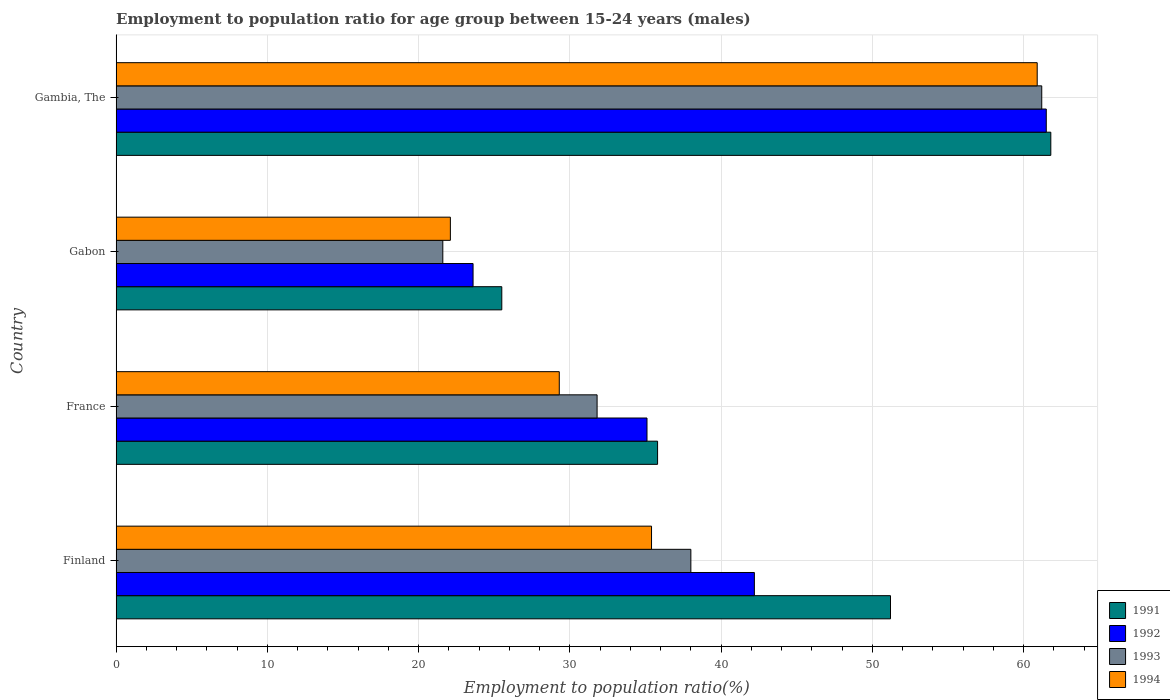Are the number of bars on each tick of the Y-axis equal?
Your response must be concise. Yes. How many bars are there on the 1st tick from the top?
Provide a succinct answer. 4. What is the label of the 3rd group of bars from the top?
Your answer should be compact. France. In how many cases, is the number of bars for a given country not equal to the number of legend labels?
Offer a very short reply. 0. What is the employment to population ratio in 1991 in France?
Your response must be concise. 35.8. Across all countries, what is the maximum employment to population ratio in 1991?
Offer a terse response. 61.8. Across all countries, what is the minimum employment to population ratio in 1994?
Your answer should be compact. 22.1. In which country was the employment to population ratio in 1994 maximum?
Provide a short and direct response. Gambia, The. In which country was the employment to population ratio in 1992 minimum?
Make the answer very short. Gabon. What is the total employment to population ratio in 1994 in the graph?
Provide a succinct answer. 147.7. What is the difference between the employment to population ratio in 1992 in France and that in Gambia, The?
Keep it short and to the point. -26.4. What is the difference between the employment to population ratio in 1994 in Gabon and the employment to population ratio in 1993 in Finland?
Make the answer very short. -15.9. What is the average employment to population ratio in 1992 per country?
Offer a terse response. 40.6. What is the difference between the employment to population ratio in 1991 and employment to population ratio in 1993 in Gambia, The?
Your answer should be very brief. 0.6. What is the ratio of the employment to population ratio in 1994 in Finland to that in Gambia, The?
Your response must be concise. 0.58. What is the difference between the highest and the second highest employment to population ratio in 1991?
Your answer should be very brief. 10.6. What is the difference between the highest and the lowest employment to population ratio in 1993?
Offer a terse response. 39.6. In how many countries, is the employment to population ratio in 1991 greater than the average employment to population ratio in 1991 taken over all countries?
Keep it short and to the point. 2. Is the sum of the employment to population ratio in 1993 in France and Gambia, The greater than the maximum employment to population ratio in 1992 across all countries?
Make the answer very short. Yes. What does the 3rd bar from the top in Gambia, The represents?
Give a very brief answer. 1992. Is it the case that in every country, the sum of the employment to population ratio in 1991 and employment to population ratio in 1992 is greater than the employment to population ratio in 1994?
Your response must be concise. Yes. How many bars are there?
Provide a succinct answer. 16. Are all the bars in the graph horizontal?
Ensure brevity in your answer.  Yes. Does the graph contain any zero values?
Provide a short and direct response. No. How are the legend labels stacked?
Keep it short and to the point. Vertical. What is the title of the graph?
Make the answer very short. Employment to population ratio for age group between 15-24 years (males). Does "1974" appear as one of the legend labels in the graph?
Your answer should be compact. No. What is the label or title of the Y-axis?
Provide a succinct answer. Country. What is the Employment to population ratio(%) of 1991 in Finland?
Offer a terse response. 51.2. What is the Employment to population ratio(%) in 1992 in Finland?
Keep it short and to the point. 42.2. What is the Employment to population ratio(%) in 1993 in Finland?
Offer a very short reply. 38. What is the Employment to population ratio(%) of 1994 in Finland?
Keep it short and to the point. 35.4. What is the Employment to population ratio(%) in 1991 in France?
Offer a terse response. 35.8. What is the Employment to population ratio(%) in 1992 in France?
Ensure brevity in your answer.  35.1. What is the Employment to population ratio(%) of 1993 in France?
Ensure brevity in your answer.  31.8. What is the Employment to population ratio(%) in 1994 in France?
Your answer should be compact. 29.3. What is the Employment to population ratio(%) of 1992 in Gabon?
Your response must be concise. 23.6. What is the Employment to population ratio(%) in 1993 in Gabon?
Make the answer very short. 21.6. What is the Employment to population ratio(%) of 1994 in Gabon?
Offer a terse response. 22.1. What is the Employment to population ratio(%) of 1991 in Gambia, The?
Make the answer very short. 61.8. What is the Employment to population ratio(%) of 1992 in Gambia, The?
Offer a terse response. 61.5. What is the Employment to population ratio(%) of 1993 in Gambia, The?
Your answer should be very brief. 61.2. What is the Employment to population ratio(%) in 1994 in Gambia, The?
Ensure brevity in your answer.  60.9. Across all countries, what is the maximum Employment to population ratio(%) of 1991?
Your response must be concise. 61.8. Across all countries, what is the maximum Employment to population ratio(%) in 1992?
Your answer should be compact. 61.5. Across all countries, what is the maximum Employment to population ratio(%) in 1993?
Ensure brevity in your answer.  61.2. Across all countries, what is the maximum Employment to population ratio(%) in 1994?
Your answer should be very brief. 60.9. Across all countries, what is the minimum Employment to population ratio(%) of 1991?
Offer a very short reply. 25.5. Across all countries, what is the minimum Employment to population ratio(%) of 1992?
Keep it short and to the point. 23.6. Across all countries, what is the minimum Employment to population ratio(%) in 1993?
Offer a terse response. 21.6. Across all countries, what is the minimum Employment to population ratio(%) in 1994?
Offer a very short reply. 22.1. What is the total Employment to population ratio(%) in 1991 in the graph?
Make the answer very short. 174.3. What is the total Employment to population ratio(%) in 1992 in the graph?
Make the answer very short. 162.4. What is the total Employment to population ratio(%) of 1993 in the graph?
Provide a short and direct response. 152.6. What is the total Employment to population ratio(%) in 1994 in the graph?
Offer a very short reply. 147.7. What is the difference between the Employment to population ratio(%) in 1992 in Finland and that in France?
Give a very brief answer. 7.1. What is the difference between the Employment to population ratio(%) of 1993 in Finland and that in France?
Your answer should be compact. 6.2. What is the difference between the Employment to population ratio(%) in 1991 in Finland and that in Gabon?
Give a very brief answer. 25.7. What is the difference between the Employment to population ratio(%) of 1992 in Finland and that in Gabon?
Provide a short and direct response. 18.6. What is the difference between the Employment to population ratio(%) of 1993 in Finland and that in Gabon?
Offer a very short reply. 16.4. What is the difference between the Employment to population ratio(%) in 1994 in Finland and that in Gabon?
Your answer should be compact. 13.3. What is the difference between the Employment to population ratio(%) in 1991 in Finland and that in Gambia, The?
Make the answer very short. -10.6. What is the difference between the Employment to population ratio(%) in 1992 in Finland and that in Gambia, The?
Keep it short and to the point. -19.3. What is the difference between the Employment to population ratio(%) in 1993 in Finland and that in Gambia, The?
Offer a very short reply. -23.2. What is the difference between the Employment to population ratio(%) in 1994 in Finland and that in Gambia, The?
Your answer should be very brief. -25.5. What is the difference between the Employment to population ratio(%) of 1991 in France and that in Gabon?
Make the answer very short. 10.3. What is the difference between the Employment to population ratio(%) of 1992 in France and that in Gambia, The?
Provide a succinct answer. -26.4. What is the difference between the Employment to population ratio(%) of 1993 in France and that in Gambia, The?
Offer a very short reply. -29.4. What is the difference between the Employment to population ratio(%) in 1994 in France and that in Gambia, The?
Your response must be concise. -31.6. What is the difference between the Employment to population ratio(%) of 1991 in Gabon and that in Gambia, The?
Provide a succinct answer. -36.3. What is the difference between the Employment to population ratio(%) in 1992 in Gabon and that in Gambia, The?
Your answer should be compact. -37.9. What is the difference between the Employment to population ratio(%) of 1993 in Gabon and that in Gambia, The?
Offer a terse response. -39.6. What is the difference between the Employment to population ratio(%) of 1994 in Gabon and that in Gambia, The?
Your answer should be very brief. -38.8. What is the difference between the Employment to population ratio(%) of 1991 in Finland and the Employment to population ratio(%) of 1992 in France?
Your response must be concise. 16.1. What is the difference between the Employment to population ratio(%) of 1991 in Finland and the Employment to population ratio(%) of 1993 in France?
Your answer should be very brief. 19.4. What is the difference between the Employment to population ratio(%) of 1991 in Finland and the Employment to population ratio(%) of 1994 in France?
Give a very brief answer. 21.9. What is the difference between the Employment to population ratio(%) in 1992 in Finland and the Employment to population ratio(%) in 1993 in France?
Your response must be concise. 10.4. What is the difference between the Employment to population ratio(%) in 1993 in Finland and the Employment to population ratio(%) in 1994 in France?
Make the answer very short. 8.7. What is the difference between the Employment to population ratio(%) of 1991 in Finland and the Employment to population ratio(%) of 1992 in Gabon?
Keep it short and to the point. 27.6. What is the difference between the Employment to population ratio(%) of 1991 in Finland and the Employment to population ratio(%) of 1993 in Gabon?
Offer a terse response. 29.6. What is the difference between the Employment to population ratio(%) in 1991 in Finland and the Employment to population ratio(%) in 1994 in Gabon?
Make the answer very short. 29.1. What is the difference between the Employment to population ratio(%) in 1992 in Finland and the Employment to population ratio(%) in 1993 in Gabon?
Provide a short and direct response. 20.6. What is the difference between the Employment to population ratio(%) of 1992 in Finland and the Employment to population ratio(%) of 1994 in Gabon?
Ensure brevity in your answer.  20.1. What is the difference between the Employment to population ratio(%) of 1991 in Finland and the Employment to population ratio(%) of 1993 in Gambia, The?
Make the answer very short. -10. What is the difference between the Employment to population ratio(%) in 1991 in Finland and the Employment to population ratio(%) in 1994 in Gambia, The?
Provide a succinct answer. -9.7. What is the difference between the Employment to population ratio(%) in 1992 in Finland and the Employment to population ratio(%) in 1993 in Gambia, The?
Provide a short and direct response. -19. What is the difference between the Employment to population ratio(%) of 1992 in Finland and the Employment to population ratio(%) of 1994 in Gambia, The?
Give a very brief answer. -18.7. What is the difference between the Employment to population ratio(%) in 1993 in Finland and the Employment to population ratio(%) in 1994 in Gambia, The?
Your response must be concise. -22.9. What is the difference between the Employment to population ratio(%) of 1991 in France and the Employment to population ratio(%) of 1993 in Gabon?
Give a very brief answer. 14.2. What is the difference between the Employment to population ratio(%) in 1991 in France and the Employment to population ratio(%) in 1994 in Gabon?
Keep it short and to the point. 13.7. What is the difference between the Employment to population ratio(%) in 1992 in France and the Employment to population ratio(%) in 1993 in Gabon?
Your answer should be compact. 13.5. What is the difference between the Employment to population ratio(%) of 1992 in France and the Employment to population ratio(%) of 1994 in Gabon?
Make the answer very short. 13. What is the difference between the Employment to population ratio(%) in 1991 in France and the Employment to population ratio(%) in 1992 in Gambia, The?
Keep it short and to the point. -25.7. What is the difference between the Employment to population ratio(%) of 1991 in France and the Employment to population ratio(%) of 1993 in Gambia, The?
Give a very brief answer. -25.4. What is the difference between the Employment to population ratio(%) in 1991 in France and the Employment to population ratio(%) in 1994 in Gambia, The?
Ensure brevity in your answer.  -25.1. What is the difference between the Employment to population ratio(%) in 1992 in France and the Employment to population ratio(%) in 1993 in Gambia, The?
Your answer should be very brief. -26.1. What is the difference between the Employment to population ratio(%) in 1992 in France and the Employment to population ratio(%) in 1994 in Gambia, The?
Provide a short and direct response. -25.8. What is the difference between the Employment to population ratio(%) in 1993 in France and the Employment to population ratio(%) in 1994 in Gambia, The?
Give a very brief answer. -29.1. What is the difference between the Employment to population ratio(%) in 1991 in Gabon and the Employment to population ratio(%) in 1992 in Gambia, The?
Offer a very short reply. -36. What is the difference between the Employment to population ratio(%) of 1991 in Gabon and the Employment to population ratio(%) of 1993 in Gambia, The?
Make the answer very short. -35.7. What is the difference between the Employment to population ratio(%) in 1991 in Gabon and the Employment to population ratio(%) in 1994 in Gambia, The?
Your answer should be compact. -35.4. What is the difference between the Employment to population ratio(%) in 1992 in Gabon and the Employment to population ratio(%) in 1993 in Gambia, The?
Give a very brief answer. -37.6. What is the difference between the Employment to population ratio(%) of 1992 in Gabon and the Employment to population ratio(%) of 1994 in Gambia, The?
Provide a succinct answer. -37.3. What is the difference between the Employment to population ratio(%) of 1993 in Gabon and the Employment to population ratio(%) of 1994 in Gambia, The?
Your answer should be very brief. -39.3. What is the average Employment to population ratio(%) in 1991 per country?
Make the answer very short. 43.58. What is the average Employment to population ratio(%) of 1992 per country?
Your response must be concise. 40.6. What is the average Employment to population ratio(%) of 1993 per country?
Provide a short and direct response. 38.15. What is the average Employment to population ratio(%) of 1994 per country?
Ensure brevity in your answer.  36.92. What is the difference between the Employment to population ratio(%) of 1991 and Employment to population ratio(%) of 1992 in Finland?
Provide a succinct answer. 9. What is the difference between the Employment to population ratio(%) of 1991 and Employment to population ratio(%) of 1994 in Finland?
Your answer should be compact. 15.8. What is the difference between the Employment to population ratio(%) of 1992 and Employment to population ratio(%) of 1993 in Finland?
Keep it short and to the point. 4.2. What is the difference between the Employment to population ratio(%) in 1993 and Employment to population ratio(%) in 1994 in Finland?
Give a very brief answer. 2.6. What is the difference between the Employment to population ratio(%) of 1991 and Employment to population ratio(%) of 1994 in France?
Your answer should be very brief. 6.5. What is the difference between the Employment to population ratio(%) of 1993 and Employment to population ratio(%) of 1994 in France?
Ensure brevity in your answer.  2.5. What is the difference between the Employment to population ratio(%) of 1991 and Employment to population ratio(%) of 1994 in Gabon?
Provide a short and direct response. 3.4. What is the difference between the Employment to population ratio(%) in 1992 and Employment to population ratio(%) in 1993 in Gabon?
Give a very brief answer. 2. What is the difference between the Employment to population ratio(%) of 1993 and Employment to population ratio(%) of 1994 in Gambia, The?
Ensure brevity in your answer.  0.3. What is the ratio of the Employment to population ratio(%) in 1991 in Finland to that in France?
Provide a short and direct response. 1.43. What is the ratio of the Employment to population ratio(%) of 1992 in Finland to that in France?
Your response must be concise. 1.2. What is the ratio of the Employment to population ratio(%) in 1993 in Finland to that in France?
Offer a terse response. 1.2. What is the ratio of the Employment to population ratio(%) of 1994 in Finland to that in France?
Your answer should be very brief. 1.21. What is the ratio of the Employment to population ratio(%) in 1991 in Finland to that in Gabon?
Your answer should be very brief. 2.01. What is the ratio of the Employment to population ratio(%) in 1992 in Finland to that in Gabon?
Your answer should be compact. 1.79. What is the ratio of the Employment to population ratio(%) of 1993 in Finland to that in Gabon?
Provide a succinct answer. 1.76. What is the ratio of the Employment to population ratio(%) in 1994 in Finland to that in Gabon?
Your answer should be compact. 1.6. What is the ratio of the Employment to population ratio(%) of 1991 in Finland to that in Gambia, The?
Give a very brief answer. 0.83. What is the ratio of the Employment to population ratio(%) of 1992 in Finland to that in Gambia, The?
Your answer should be very brief. 0.69. What is the ratio of the Employment to population ratio(%) in 1993 in Finland to that in Gambia, The?
Provide a short and direct response. 0.62. What is the ratio of the Employment to population ratio(%) in 1994 in Finland to that in Gambia, The?
Offer a very short reply. 0.58. What is the ratio of the Employment to population ratio(%) in 1991 in France to that in Gabon?
Offer a very short reply. 1.4. What is the ratio of the Employment to population ratio(%) of 1992 in France to that in Gabon?
Ensure brevity in your answer.  1.49. What is the ratio of the Employment to population ratio(%) of 1993 in France to that in Gabon?
Your response must be concise. 1.47. What is the ratio of the Employment to population ratio(%) of 1994 in France to that in Gabon?
Offer a terse response. 1.33. What is the ratio of the Employment to population ratio(%) in 1991 in France to that in Gambia, The?
Provide a short and direct response. 0.58. What is the ratio of the Employment to population ratio(%) of 1992 in France to that in Gambia, The?
Offer a terse response. 0.57. What is the ratio of the Employment to population ratio(%) in 1993 in France to that in Gambia, The?
Offer a terse response. 0.52. What is the ratio of the Employment to population ratio(%) of 1994 in France to that in Gambia, The?
Keep it short and to the point. 0.48. What is the ratio of the Employment to population ratio(%) in 1991 in Gabon to that in Gambia, The?
Provide a succinct answer. 0.41. What is the ratio of the Employment to population ratio(%) of 1992 in Gabon to that in Gambia, The?
Keep it short and to the point. 0.38. What is the ratio of the Employment to population ratio(%) in 1993 in Gabon to that in Gambia, The?
Your response must be concise. 0.35. What is the ratio of the Employment to population ratio(%) in 1994 in Gabon to that in Gambia, The?
Your answer should be very brief. 0.36. What is the difference between the highest and the second highest Employment to population ratio(%) of 1992?
Offer a very short reply. 19.3. What is the difference between the highest and the second highest Employment to population ratio(%) of 1993?
Your response must be concise. 23.2. What is the difference between the highest and the second highest Employment to population ratio(%) of 1994?
Keep it short and to the point. 25.5. What is the difference between the highest and the lowest Employment to population ratio(%) in 1991?
Your response must be concise. 36.3. What is the difference between the highest and the lowest Employment to population ratio(%) of 1992?
Ensure brevity in your answer.  37.9. What is the difference between the highest and the lowest Employment to population ratio(%) of 1993?
Your answer should be compact. 39.6. What is the difference between the highest and the lowest Employment to population ratio(%) of 1994?
Your response must be concise. 38.8. 